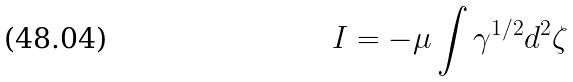Convert formula to latex. <formula><loc_0><loc_0><loc_500><loc_500>I = - \mu \int \gamma ^ { 1 / 2 } d ^ { 2 } \zeta</formula> 